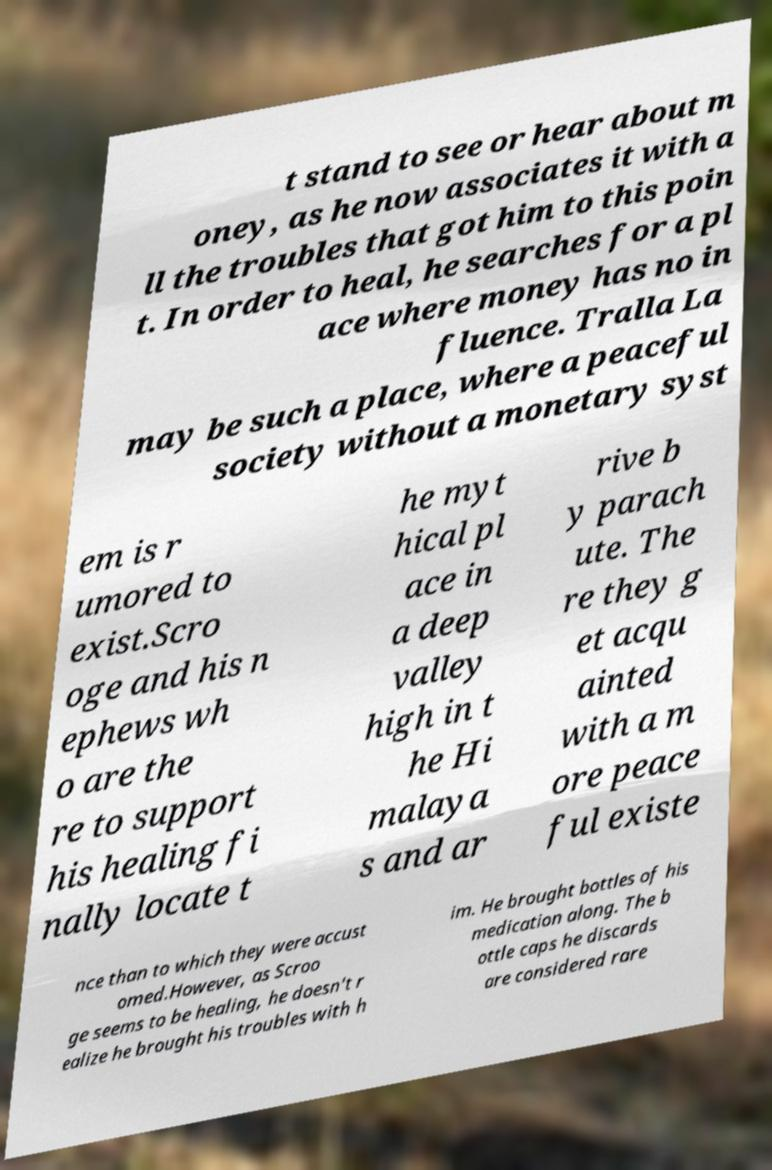For documentation purposes, I need the text within this image transcribed. Could you provide that? t stand to see or hear about m oney, as he now associates it with a ll the troubles that got him to this poin t. In order to heal, he searches for a pl ace where money has no in fluence. Tralla La may be such a place, where a peaceful society without a monetary syst em is r umored to exist.Scro oge and his n ephews wh o are the re to support his healing fi nally locate t he myt hical pl ace in a deep valley high in t he Hi malaya s and ar rive b y parach ute. The re they g et acqu ainted with a m ore peace ful existe nce than to which they were accust omed.However, as Scroo ge seems to be healing, he doesn't r ealize he brought his troubles with h im. He brought bottles of his medication along. The b ottle caps he discards are considered rare 